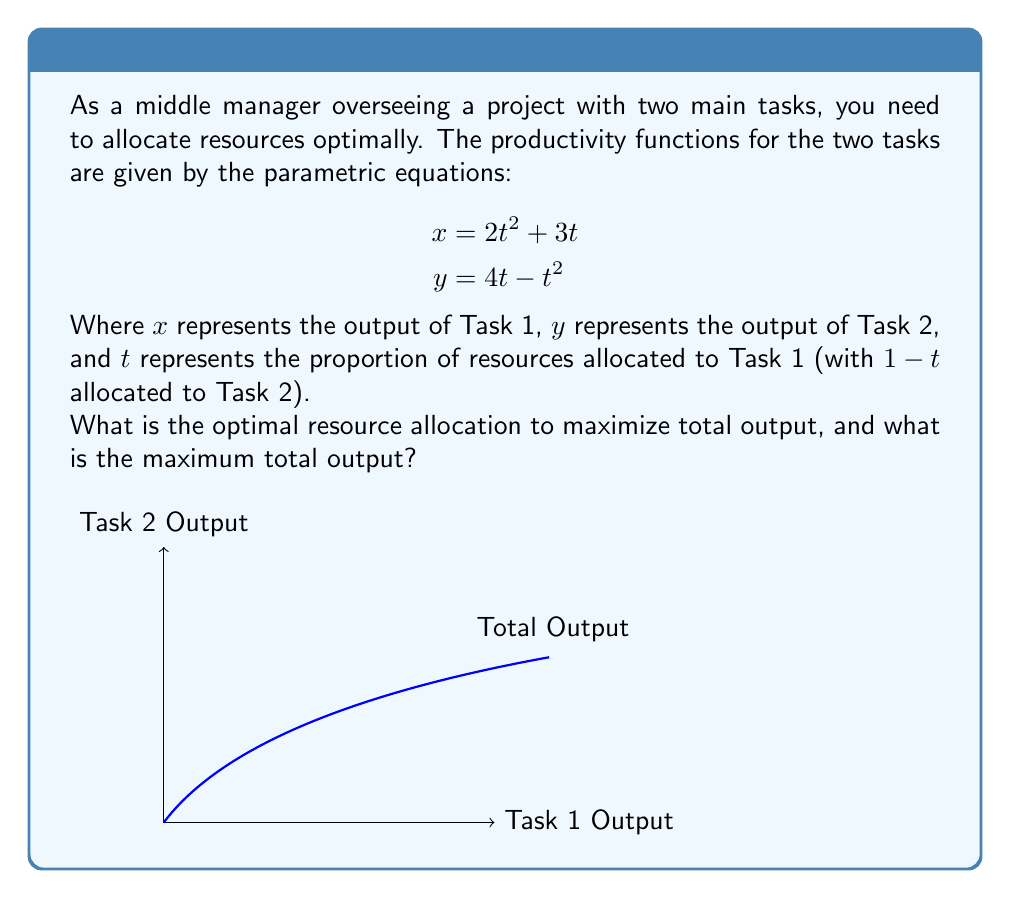Show me your answer to this math problem. To solve this problem, we'll follow these steps:

1) The total output is given by $z = x + y$. Substituting the parametric equations:

   $$z = (2t^2 + 3t) + (4t - t^2) = t^2 + 7t$$

2) To find the maximum of $z$, we need to find where its derivative with respect to $t$ is zero:

   $$\frac{dz}{dt} = 2t + 7$$

3) Set this equal to zero and solve:

   $$2t + 7 = 0$$
   $$2t = -7$$
   $$t = -\frac{7}{2}$$

4) However, since $t$ represents a proportion, it must be between 0 and 1. The negative value is outside our domain, so we need to check the endpoints of our interval [0,1].

5) Evaluate $z$ at $t=0$ and $t=1$:

   At $t=0$: $z = 0^2 + 7(0) = 0$
   At $t=1$: $z = 1^2 + 7(1) = 8$

6) The maximum occurs at $t=1$, meaning all resources should be allocated to Task 1.

7) To find the outputs at this allocation:

   $$x = 2(1)^2 + 3(1) = 5$$
   $$y = 4(1) - (1)^2 = 3$$

8) The total maximum output is indeed $5 + 3 = 8$.
Answer: Optimal allocation: 100% to Task 1 (t=1). Maximum total output: 8 units. 